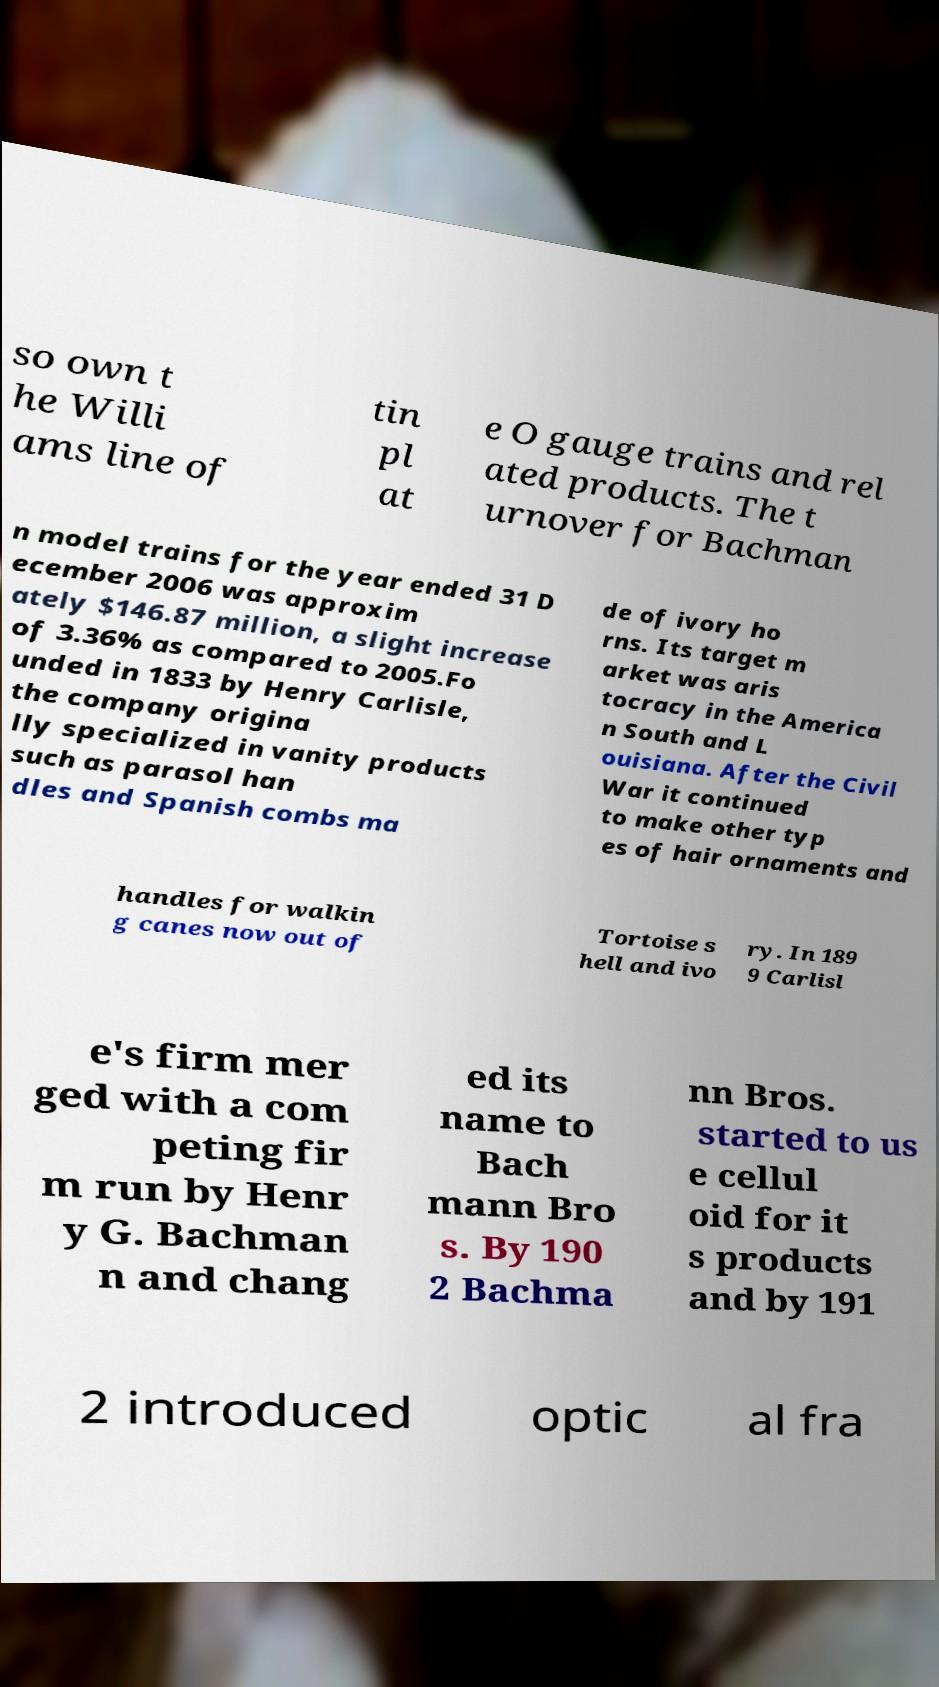Please identify and transcribe the text found in this image. so own t he Willi ams line of tin pl at e O gauge trains and rel ated products. The t urnover for Bachman n model trains for the year ended 31 D ecember 2006 was approxim ately $146.87 million, a slight increase of 3.36% as compared to 2005.Fo unded in 1833 by Henry Carlisle, the company origina lly specialized in vanity products such as parasol han dles and Spanish combs ma de of ivory ho rns. Its target m arket was aris tocracy in the America n South and L ouisiana. After the Civil War it continued to make other typ es of hair ornaments and handles for walkin g canes now out of Tortoise s hell and ivo ry. In 189 9 Carlisl e's firm mer ged with a com peting fir m run by Henr y G. Bachman n and chang ed its name to Bach mann Bro s. By 190 2 Bachma nn Bros. started to us e cellul oid for it s products and by 191 2 introduced optic al fra 